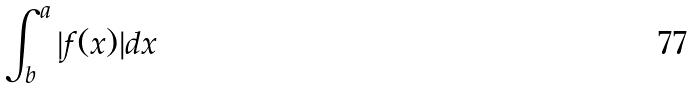<formula> <loc_0><loc_0><loc_500><loc_500>\int _ { b } ^ { a } | f ( x ) | d x</formula> 